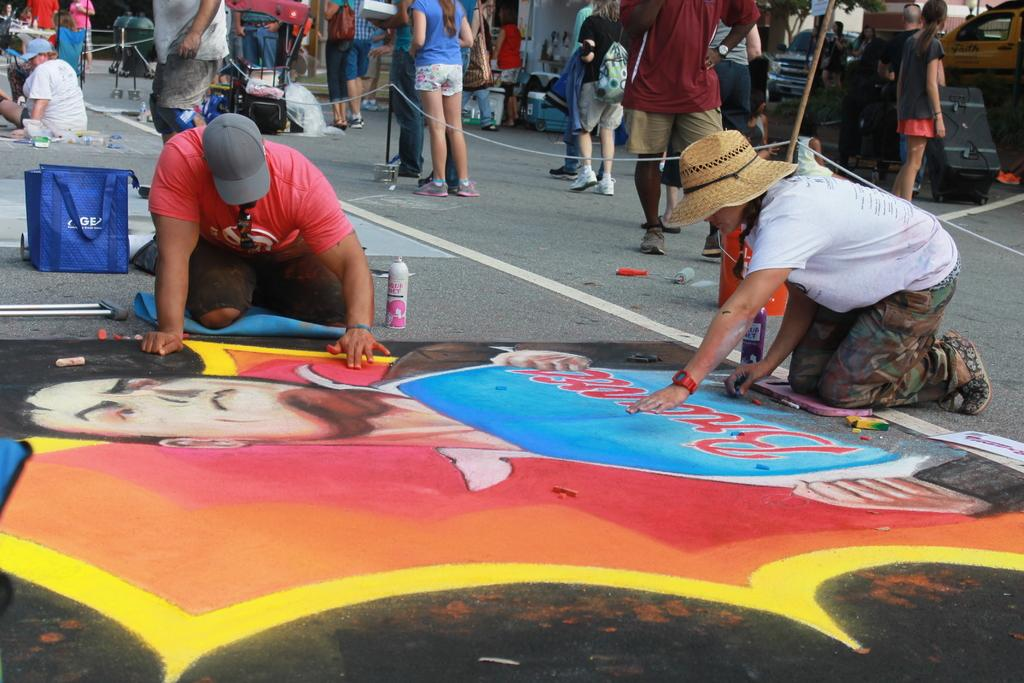What are the two persons in the image doing? The two persons in the image are painting. Where are they painting? They are painting on the road. What can be seen in the background of the image? There are people walking in the background of the image. What type of cable can be seen connecting the two persons in the image? There is no cable connecting the two persons in the image; they are painting on the road. 